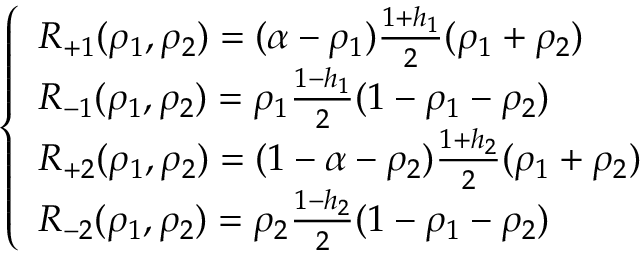Convert formula to latex. <formula><loc_0><loc_0><loc_500><loc_500>\left \{ \begin{array} { l l } { R _ { + 1 } ( \rho _ { 1 } , \rho _ { 2 } ) = ( \alpha - \rho _ { 1 } ) \frac { 1 + h _ { 1 } } { 2 } ( \rho _ { 1 } + \rho _ { 2 } ) } \\ { R _ { - 1 } ( \rho _ { 1 } , \rho _ { 2 } ) = \rho _ { 1 } \frac { 1 - h _ { 1 } } { 2 } ( 1 - \rho _ { 1 } - \rho _ { 2 } ) } \\ { R _ { + 2 } ( \rho _ { 1 } , \rho _ { 2 } ) = ( 1 - \alpha - \rho _ { 2 } ) \frac { 1 + h _ { 2 } } { 2 } ( \rho _ { 1 } + \rho _ { 2 } ) } \\ { R _ { - 2 } ( \rho _ { 1 } , \rho _ { 2 } ) = \rho _ { 2 } \frac { 1 - h _ { 2 } } { 2 } ( 1 - \rho _ { 1 } - \rho _ { 2 } ) } \end{array}</formula> 